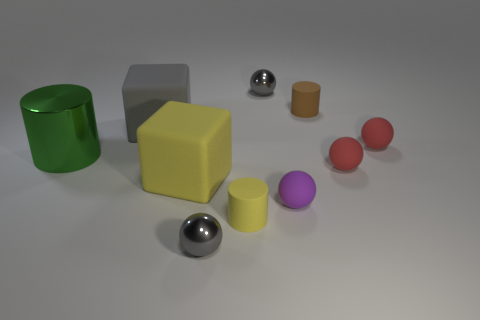How many spheres are there and what colors are they? There are three spheres in the image, two are identical and red, and one is silver-colored. 